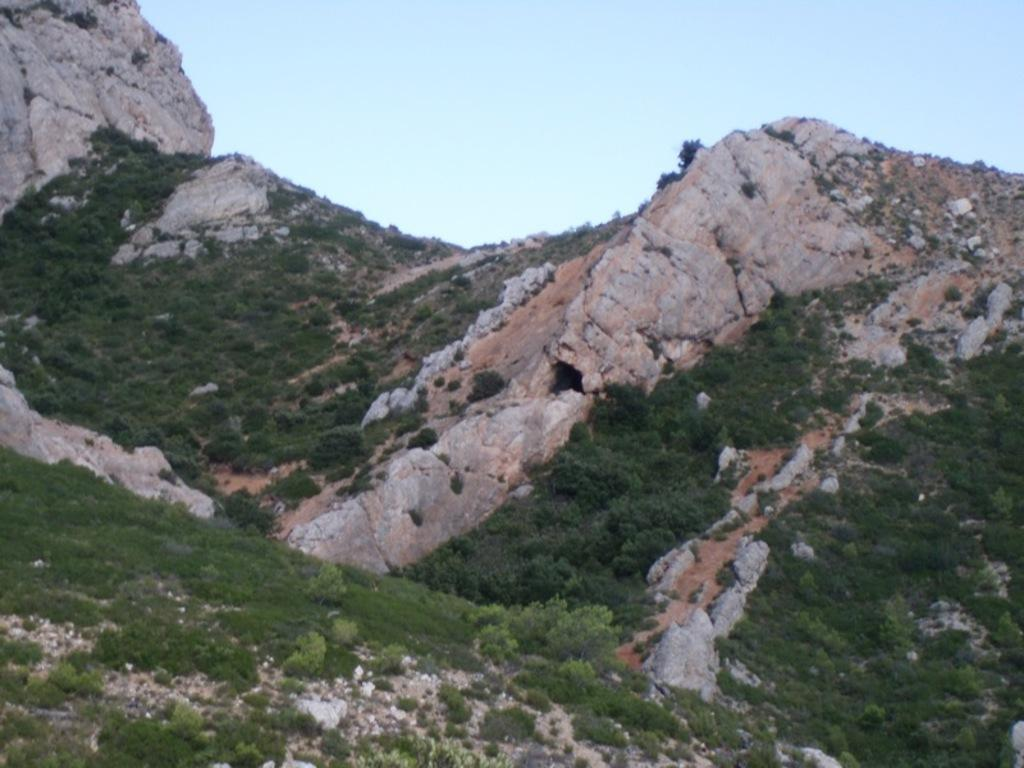What type of vegetation can be seen in the image? There are trees in the image. What geographical feature is present in the image? There is a mountain in the image. What can be seen in the background of the image? The sky is visible in the background of the image. What type of notebook is being used by the animal in the image? There is no animal or notebook present in the image. What type of rake is being used by the trees in the image? There is no rake present in the image, and trees do not use rakes. 